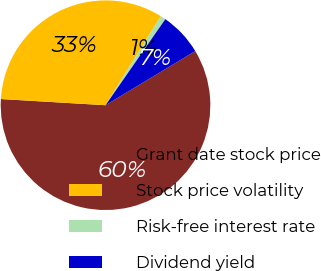Convert chart. <chart><loc_0><loc_0><loc_500><loc_500><pie_chart><fcel>Grant date stock price<fcel>Stock price volatility<fcel>Risk-free interest rate<fcel>Dividend yield<nl><fcel>59.58%<fcel>32.91%<fcel>0.82%<fcel>6.69%<nl></chart> 